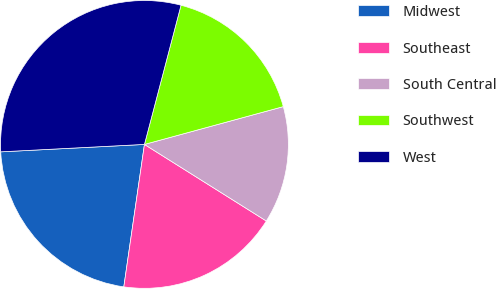Convert chart. <chart><loc_0><loc_0><loc_500><loc_500><pie_chart><fcel>Midwest<fcel>Southeast<fcel>South Central<fcel>Southwest<fcel>West<nl><fcel>21.89%<fcel>18.36%<fcel>13.16%<fcel>16.68%<fcel>29.91%<nl></chart> 